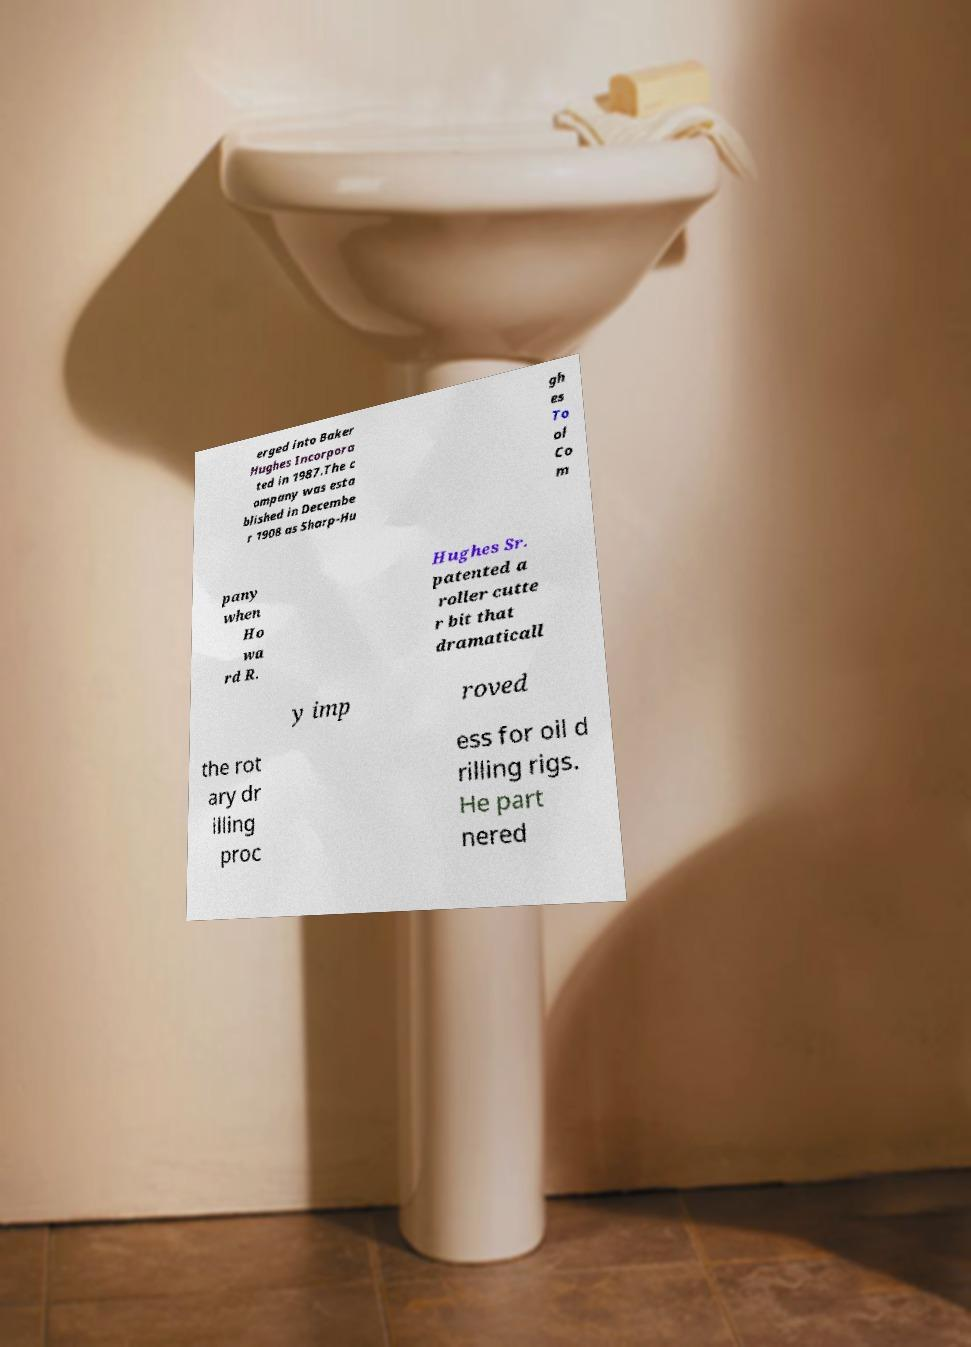Can you read and provide the text displayed in the image?This photo seems to have some interesting text. Can you extract and type it out for me? erged into Baker Hughes Incorpora ted in 1987.The c ompany was esta blished in Decembe r 1908 as Sharp-Hu gh es To ol Co m pany when Ho wa rd R. Hughes Sr. patented a roller cutte r bit that dramaticall y imp roved the rot ary dr illing proc ess for oil d rilling rigs. He part nered 